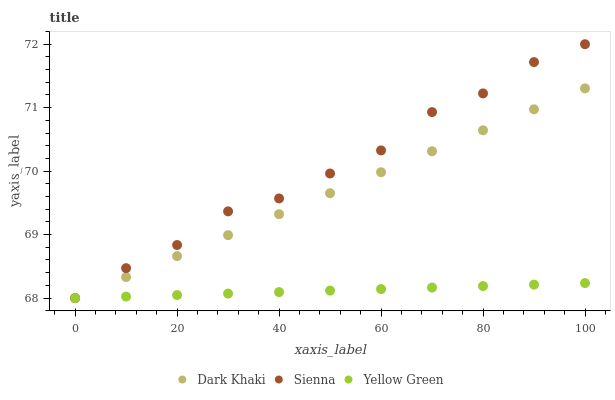Does Yellow Green have the minimum area under the curve?
Answer yes or no. Yes. Does Sienna have the maximum area under the curve?
Answer yes or no. Yes. Does Sienna have the minimum area under the curve?
Answer yes or no. No. Does Yellow Green have the maximum area under the curve?
Answer yes or no. No. Is Dark Khaki the smoothest?
Answer yes or no. Yes. Is Sienna the roughest?
Answer yes or no. Yes. Is Yellow Green the smoothest?
Answer yes or no. No. Is Yellow Green the roughest?
Answer yes or no. No. Does Dark Khaki have the lowest value?
Answer yes or no. Yes. Does Sienna have the highest value?
Answer yes or no. Yes. Does Yellow Green have the highest value?
Answer yes or no. No. Does Dark Khaki intersect Sienna?
Answer yes or no. Yes. Is Dark Khaki less than Sienna?
Answer yes or no. No. Is Dark Khaki greater than Sienna?
Answer yes or no. No. 